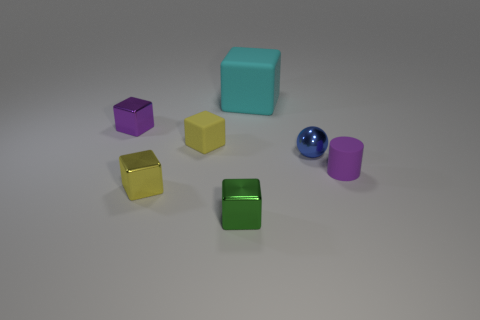Are there any other things that have the same shape as the blue shiny thing?
Provide a succinct answer. No. What number of small purple objects are both to the right of the small blue sphere and on the left side of the yellow shiny block?
Offer a terse response. 0. The purple metallic thing that is the same shape as the green metal thing is what size?
Give a very brief answer. Small. What number of small purple cylinders are made of the same material as the green object?
Your answer should be very brief. 0. Are there fewer cubes that are behind the tiny blue metal thing than cyan blocks?
Offer a terse response. No. How many small blue metal objects are there?
Ensure brevity in your answer.  1. What number of tiny matte things are the same color as the cylinder?
Provide a short and direct response. 0. Does the purple metal thing have the same shape as the large thing?
Ensure brevity in your answer.  Yes. There is a cyan rubber thing on the left side of the metallic thing right of the big rubber thing; what size is it?
Your answer should be very brief. Large. Are there any balls of the same size as the yellow metal object?
Offer a very short reply. Yes. 